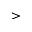<formula> <loc_0><loc_0><loc_500><loc_500>></formula> 